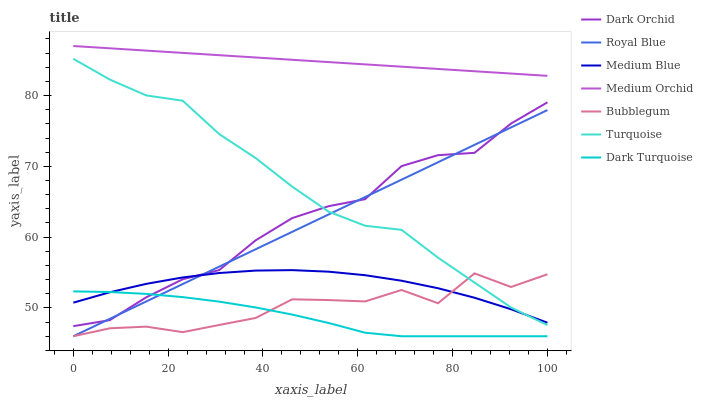Does Dark Turquoise have the minimum area under the curve?
Answer yes or no. Yes. Does Medium Orchid have the maximum area under the curve?
Answer yes or no. Yes. Does Medium Orchid have the minimum area under the curve?
Answer yes or no. No. Does Dark Turquoise have the maximum area under the curve?
Answer yes or no. No. Is Medium Orchid the smoothest?
Answer yes or no. Yes. Is Bubblegum the roughest?
Answer yes or no. Yes. Is Dark Turquoise the smoothest?
Answer yes or no. No. Is Dark Turquoise the roughest?
Answer yes or no. No. Does Dark Turquoise have the lowest value?
Answer yes or no. Yes. Does Medium Orchid have the lowest value?
Answer yes or no. No. Does Medium Orchid have the highest value?
Answer yes or no. Yes. Does Dark Turquoise have the highest value?
Answer yes or no. No. Is Royal Blue less than Medium Orchid?
Answer yes or no. Yes. Is Medium Orchid greater than Dark Orchid?
Answer yes or no. Yes. Does Royal Blue intersect Medium Blue?
Answer yes or no. Yes. Is Royal Blue less than Medium Blue?
Answer yes or no. No. Is Royal Blue greater than Medium Blue?
Answer yes or no. No. Does Royal Blue intersect Medium Orchid?
Answer yes or no. No. 